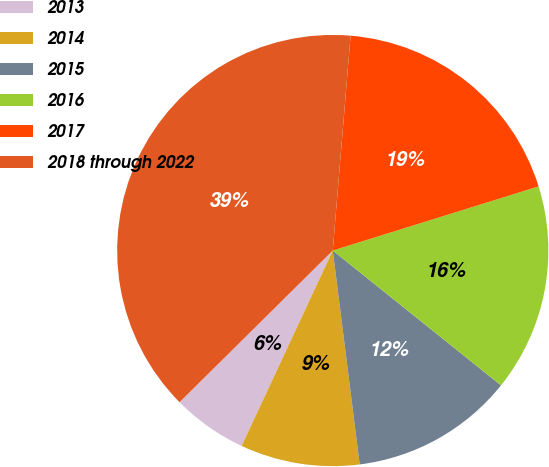Convert chart to OTSL. <chart><loc_0><loc_0><loc_500><loc_500><pie_chart><fcel>2013<fcel>2014<fcel>2015<fcel>2016<fcel>2017<fcel>2018 through 2022<nl><fcel>5.63%<fcel>8.94%<fcel>12.25%<fcel>15.56%<fcel>18.87%<fcel>38.73%<nl></chart> 